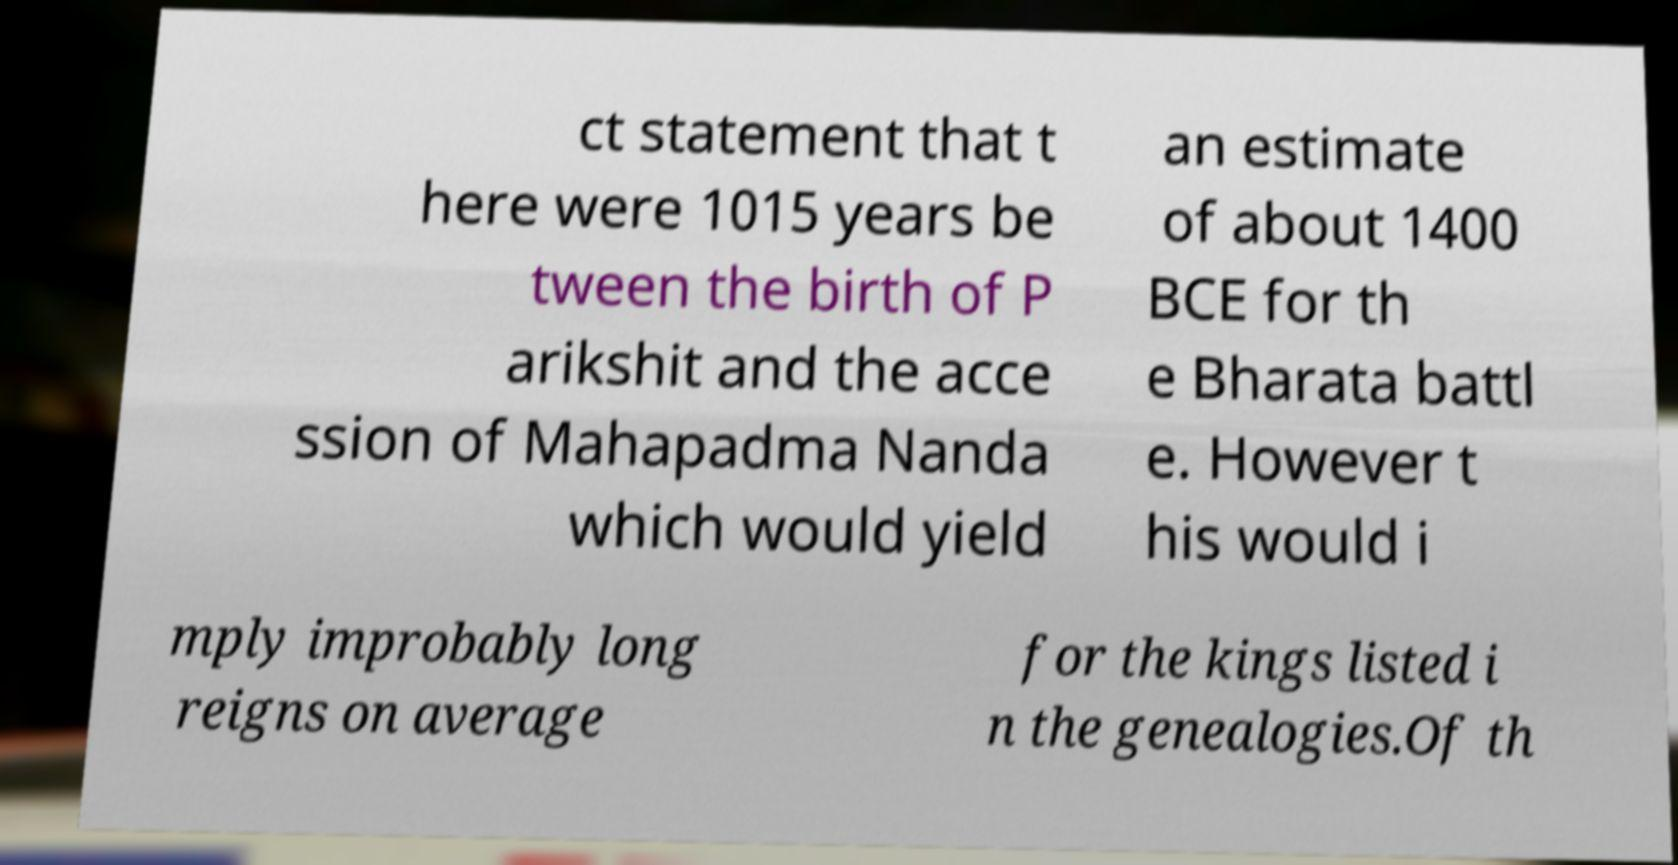Can you accurately transcribe the text from the provided image for me? ct statement that t here were 1015 years be tween the birth of P arikshit and the acce ssion of Mahapadma Nanda which would yield an estimate of about 1400 BCE for th e Bharata battl e. However t his would i mply improbably long reigns on average for the kings listed i n the genealogies.Of th 